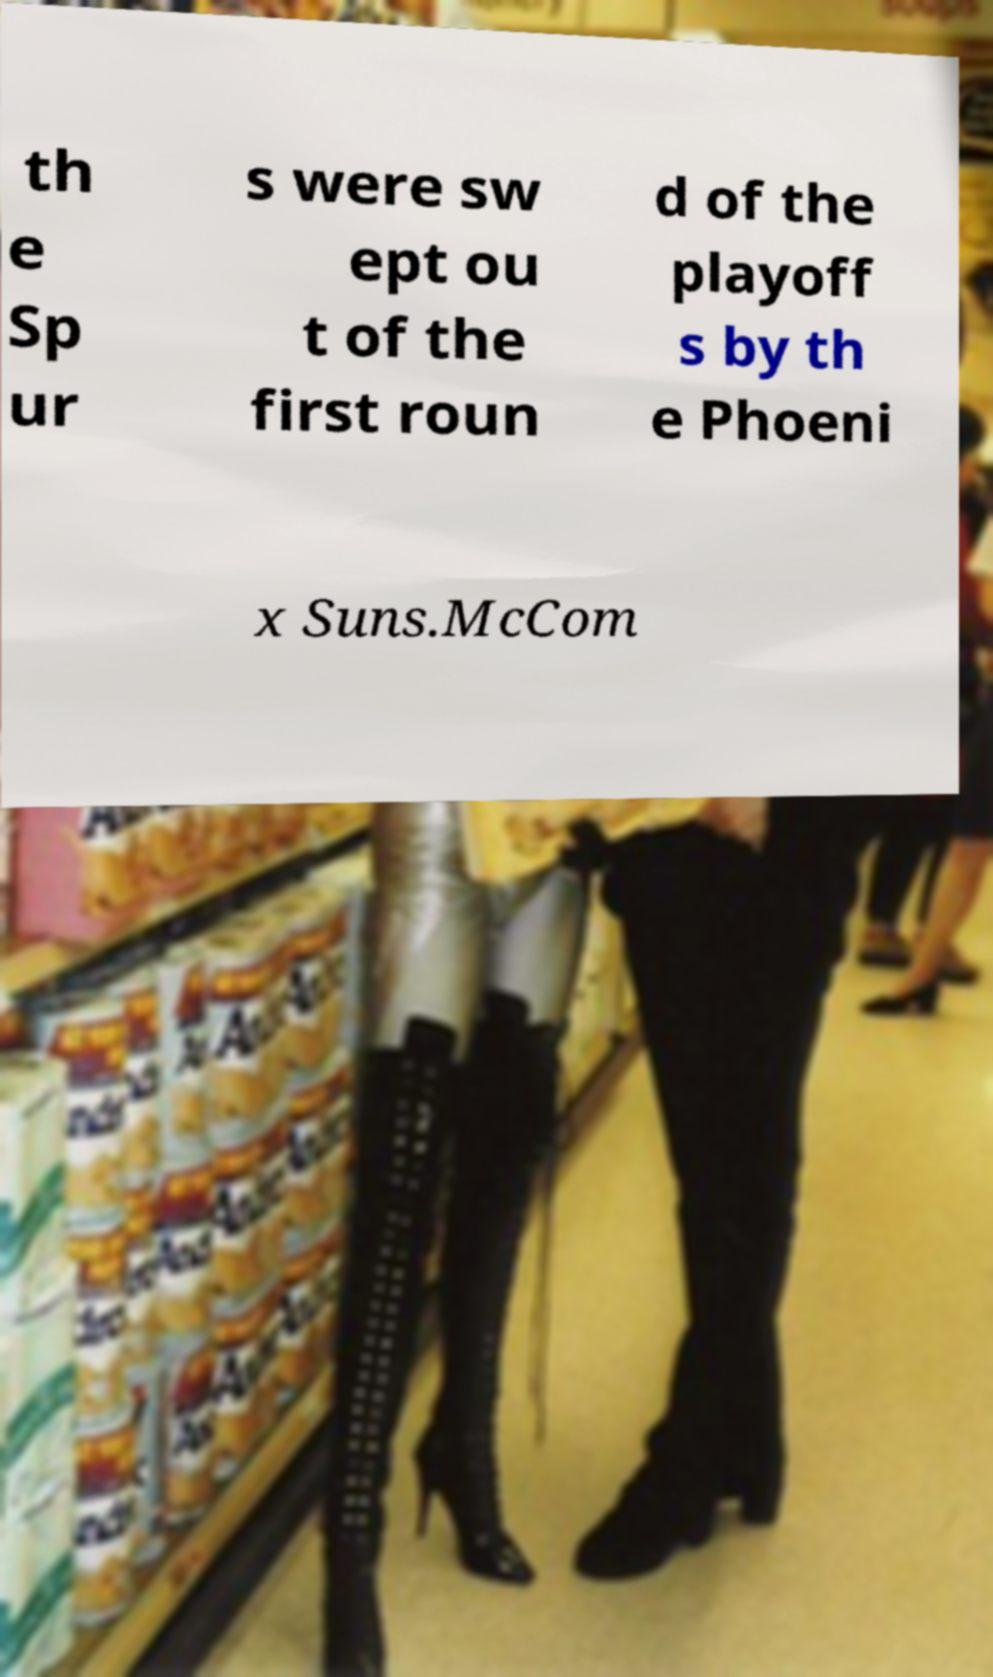For documentation purposes, I need the text within this image transcribed. Could you provide that? th e Sp ur s were sw ept ou t of the first roun d of the playoff s by th e Phoeni x Suns.McCom 